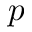<formula> <loc_0><loc_0><loc_500><loc_500>p</formula> 